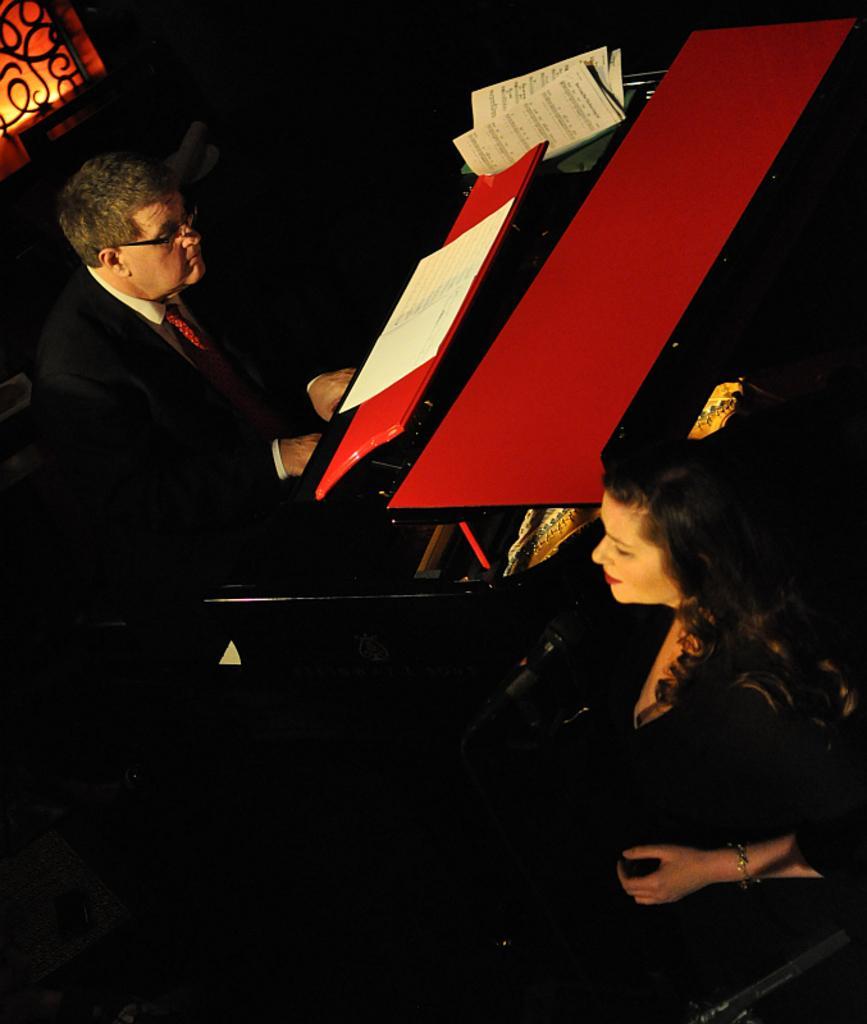Please provide a concise description of this image. In this picture we can see a man wearing spectacles , playing musical instrument. It is a book here. We can see any women here in front of a mike. 